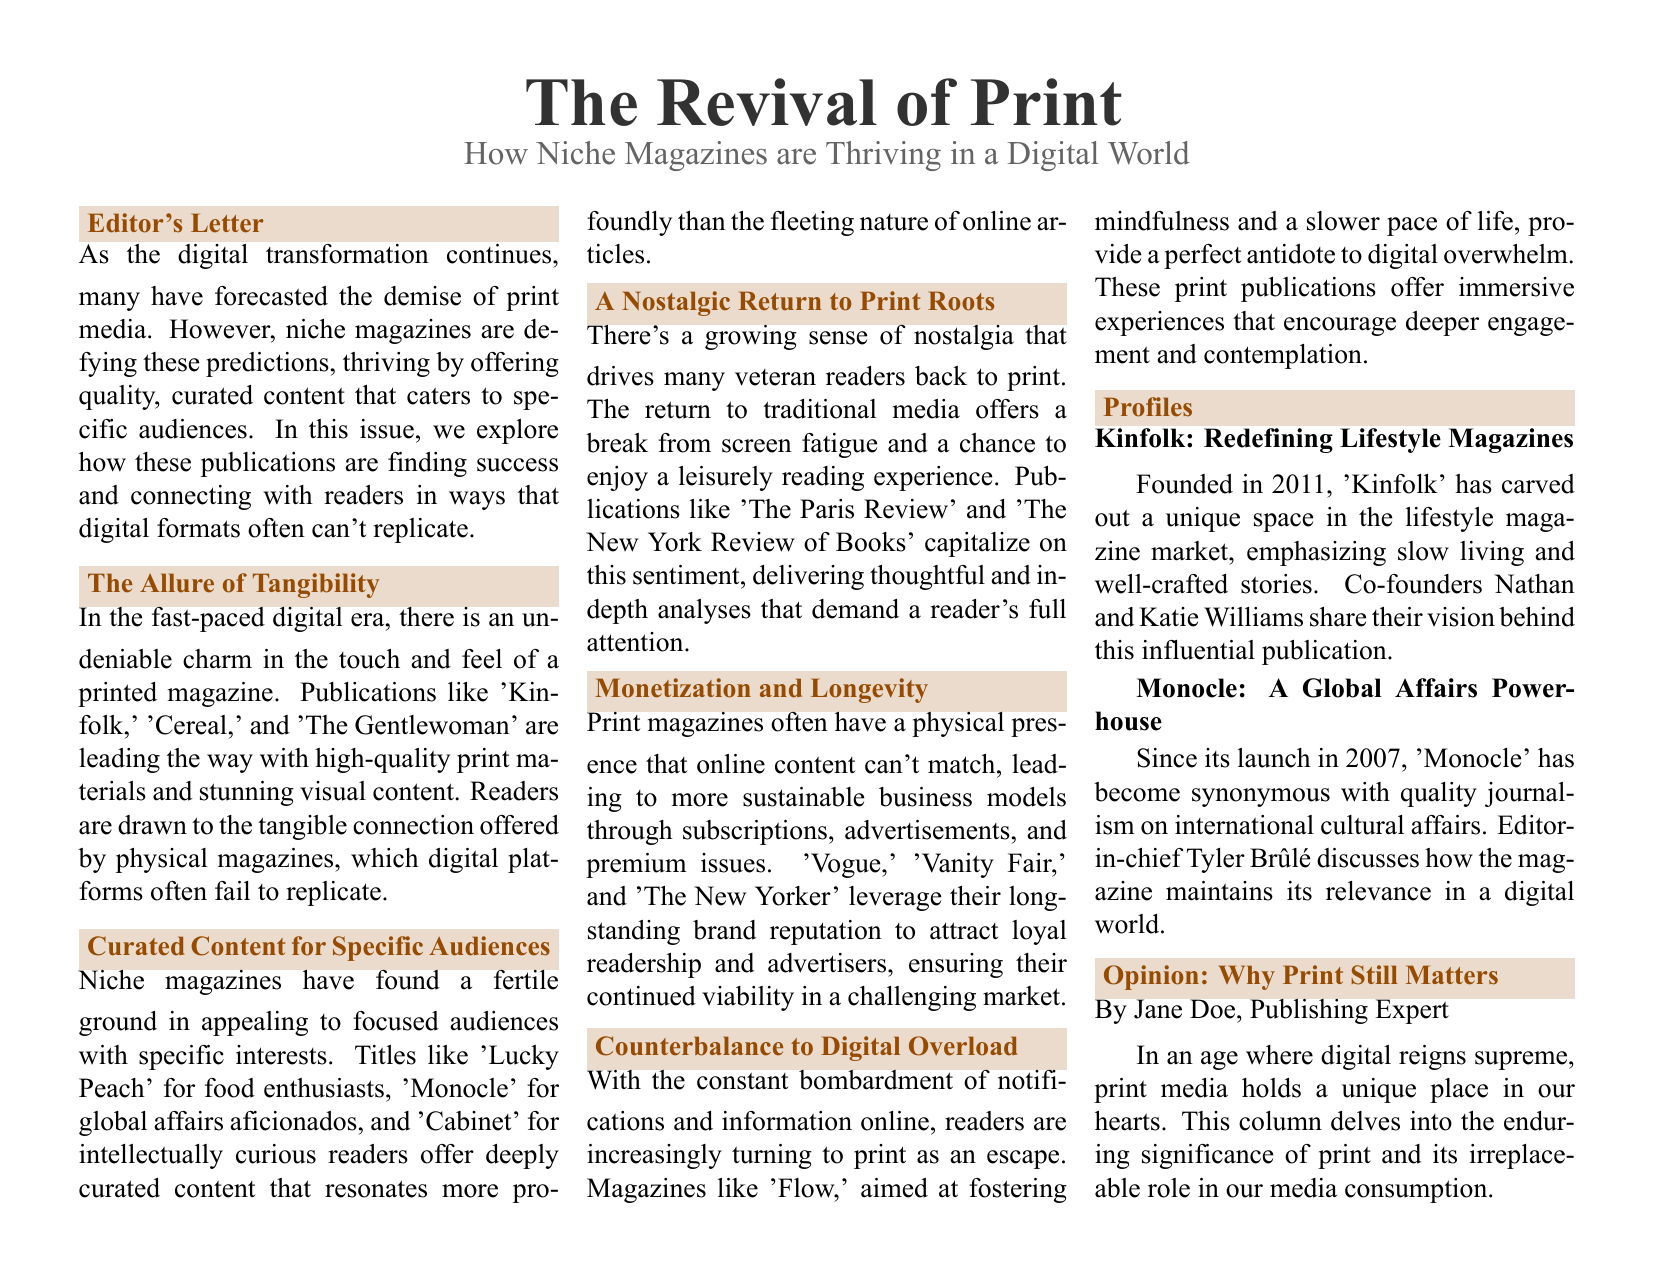What is the title of the document? The title of the document is displayed prominently at the beginning, highlighting the overall theme.
Answer: The Revival of Print What is the subheadline of the document? The subheadline provides a brief elaboration on the main title, indicating the focus of the content.
Answer: How Niche Magazines are Thriving in a Digital World Who is the author of the opinion column? The document specifically names the author of the opinion piece, which indicates the source of the views expressed.
Answer: Jane Doe Which magazine focuses on food enthusiasts? The document lists various niche magazines and identifies one that specifically caters to food interests.
Answer: Lucky Peach What year was Kinfolk founded? The document provides details on the founding year of Kinfolk within its magazine profile section.
Answer: 2011 How many sections are there in the document? The number of sections can be counted based on the layout of the document, which organizes content thematically.
Answer: Six What is a key characteristic of niche magazines according to the document? The document summarizes a major appeal of niche magazines, highlighting a specific aspect of their content.
Answer: Curated content Which magazine is mentioned as providing an antidote to digital overwhelm? The document explicitly mentions a magazine that aims to help readers manage digital stress.
Answer: Flow What is the primary focus of the magazine Monocle? The document specifies the central theme of Monocle, indicating the type of content it is known for.
Answer: Global affairs 